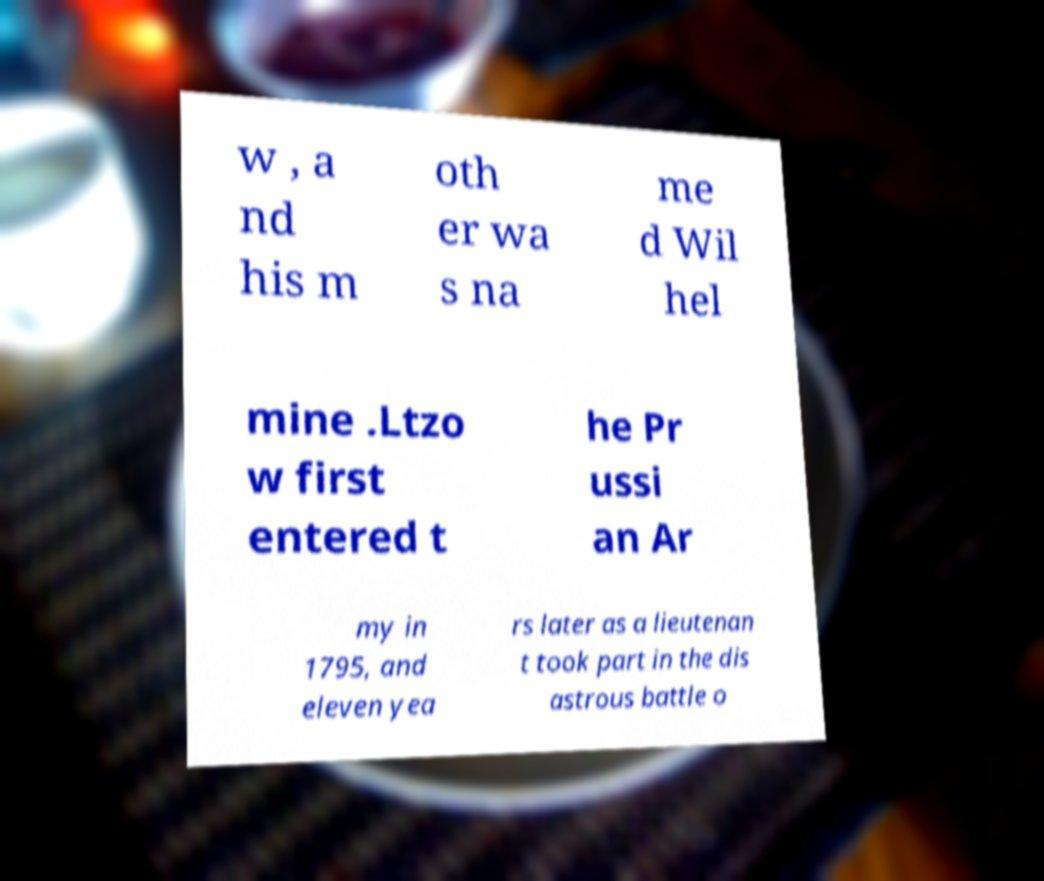Can you read and provide the text displayed in the image?This photo seems to have some interesting text. Can you extract and type it out for me? w , a nd his m oth er wa s na me d Wil hel mine .Ltzo w first entered t he Pr ussi an Ar my in 1795, and eleven yea rs later as a lieutenan t took part in the dis astrous battle o 